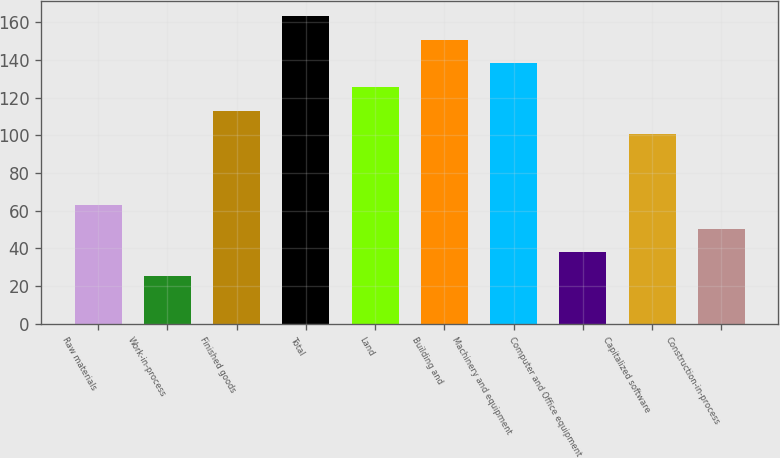Convert chart to OTSL. <chart><loc_0><loc_0><loc_500><loc_500><bar_chart><fcel>Raw materials<fcel>Work-in-process<fcel>Finished goods<fcel>Total<fcel>Land<fcel>Building and<fcel>Machinery and equipment<fcel>Computer and Office equipment<fcel>Capitalized software<fcel>Construction-in-process<nl><fcel>63.1<fcel>25.54<fcel>113.18<fcel>163.26<fcel>125.7<fcel>150.74<fcel>138.22<fcel>38.06<fcel>100.66<fcel>50.58<nl></chart> 